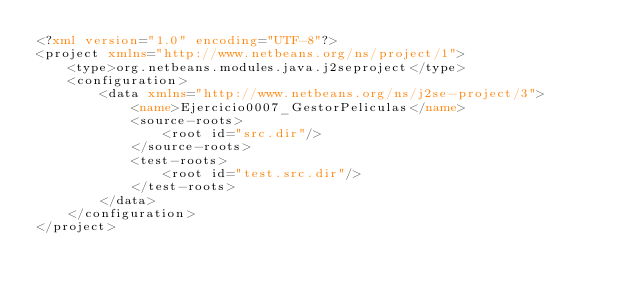<code> <loc_0><loc_0><loc_500><loc_500><_XML_><?xml version="1.0" encoding="UTF-8"?>
<project xmlns="http://www.netbeans.org/ns/project/1">
    <type>org.netbeans.modules.java.j2seproject</type>
    <configuration>
        <data xmlns="http://www.netbeans.org/ns/j2se-project/3">
            <name>Ejercicio0007_GestorPeliculas</name>
            <source-roots>
                <root id="src.dir"/>
            </source-roots>
            <test-roots>
                <root id="test.src.dir"/>
            </test-roots>
        </data>
    </configuration>
</project>
</code> 